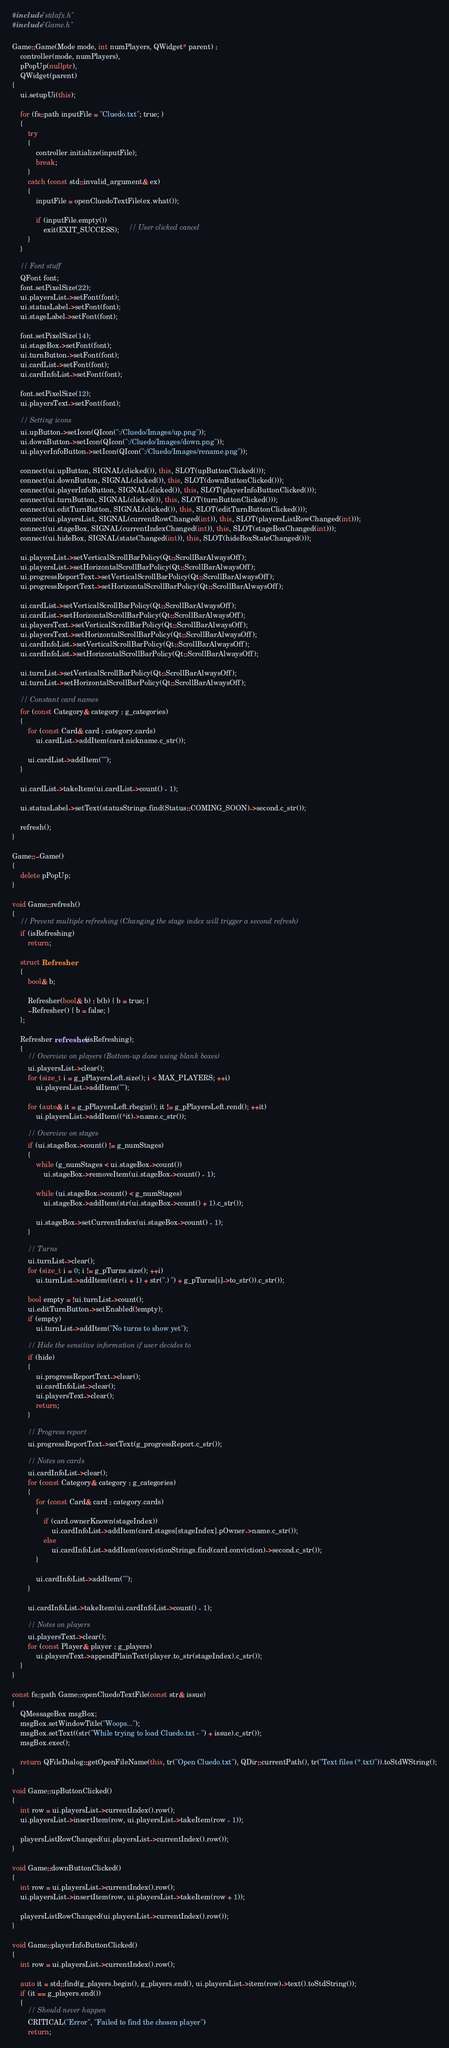<code> <loc_0><loc_0><loc_500><loc_500><_C++_>#include "stdafx.h"
#include "Game.h"

Game::Game(Mode mode, int numPlayers, QWidget* parent) :
    controller(mode, numPlayers),
    pPopUp(nullptr),
    QWidget(parent)
{
    ui.setupUi(this);

    for (fs::path inputFile = "Cluedo.txt"; true; )
    {
        try
        {
            controller.initialize(inputFile);
            break;
        }
        catch (const std::invalid_argument& ex)
        {
            inputFile = openCluedoTextFile(ex.what());

            if (inputFile.empty())
                exit(EXIT_SUCCESS);     // User clicked cancel
        }
    }

    // Font stuff
    QFont font;
    font.setPixelSize(22);
    ui.playersList->setFont(font);
    ui.statusLabel->setFont(font);
    ui.stageLabel->setFont(font);
    
    font.setPixelSize(14);
    ui.stageBox->setFont(font);
    ui.turnButton->setFont(font);
    ui.cardList->setFont(font);
    ui.cardInfoList->setFont(font);

    font.setPixelSize(12);
    ui.playersText->setFont(font);

    // Setting icons
    ui.upButton->setIcon(QIcon(":/Cluedo/Images/up.png"));
    ui.downButton->setIcon(QIcon(":/Cluedo/Images/down.png"));
    ui.playerInfoButton->setIcon(QIcon(":/Cluedo/Images/rename.png"));

    connect(ui.upButton, SIGNAL(clicked()), this, SLOT(upButtonClicked()));
    connect(ui.downButton, SIGNAL(clicked()), this, SLOT(downButtonClicked()));
    connect(ui.playerInfoButton, SIGNAL(clicked()), this, SLOT(playerInfoButtonClicked()));
    connect(ui.turnButton, SIGNAL(clicked()), this, SLOT(turnButtonClicked()));
    connect(ui.editTurnButton, SIGNAL(clicked()), this, SLOT(editTurnButtonClicked()));
    connect(ui.playersList, SIGNAL(currentRowChanged(int)), this, SLOT(playersListRowChanged(int)));
    connect(ui.stageBox, SIGNAL(currentIndexChanged(int)), this, SLOT(stageBoxChanged(int)));
    connect(ui.hideBox, SIGNAL(stateChanged(int)), this, SLOT(hideBoxStateChanged()));

    ui.playersList->setVerticalScrollBarPolicy(Qt::ScrollBarAlwaysOff);
    ui.playersList->setHorizontalScrollBarPolicy(Qt::ScrollBarAlwaysOff);
    ui.progressReportText->setVerticalScrollBarPolicy(Qt::ScrollBarAlwaysOff);
    ui.progressReportText->setHorizontalScrollBarPolicy(Qt::ScrollBarAlwaysOff);

    ui.cardList->setVerticalScrollBarPolicy(Qt::ScrollBarAlwaysOff);
    ui.cardList->setHorizontalScrollBarPolicy(Qt::ScrollBarAlwaysOff);
    ui.playersText->setVerticalScrollBarPolicy(Qt::ScrollBarAlwaysOff);
    ui.playersText->setHorizontalScrollBarPolicy(Qt::ScrollBarAlwaysOff);
    ui.cardInfoList->setVerticalScrollBarPolicy(Qt::ScrollBarAlwaysOff);
    ui.cardInfoList->setHorizontalScrollBarPolicy(Qt::ScrollBarAlwaysOff);

    ui.turnList->setVerticalScrollBarPolicy(Qt::ScrollBarAlwaysOff);
    ui.turnList->setHorizontalScrollBarPolicy(Qt::ScrollBarAlwaysOff);

    // Constant card names
    for (const Category& category : g_categories)
    {
        for (const Card& card : category.cards)
            ui.cardList->addItem(card.nickname.c_str());

        ui.cardList->addItem("");
    }

    ui.cardList->takeItem(ui.cardList->count() - 1);

    ui.statusLabel->setText(statusStrings.find(Status::COMING_SOON)->second.c_str());

    refresh();
}

Game::~Game()
{
    delete pPopUp;
}

void Game::refresh()
{
    // Prevent multiple refreshing (Changing the stage index will trigger a second refresh)
    if (isRefreshing)
        return;

    struct Refresher
    {
        bool& b;

        Refresher(bool& b) : b(b) { b = true; }
        ~Refresher() { b = false; }
    };

    Refresher refresher(isRefreshing);
    {
        // Overview on players (Bottom-up done using blank boxes)
        ui.playersList->clear();
        for (size_t i = g_pPlayersLeft.size(); i < MAX_PLAYERS; ++i)
            ui.playersList->addItem("");

        for (auto& it = g_pPlayersLeft.rbegin(); it != g_pPlayersLeft.rend(); ++it)
            ui.playersList->addItem((*it)->name.c_str());

        // Overview on stages
        if (ui.stageBox->count() != g_numStages)
        {
            while (g_numStages < ui.stageBox->count())
                ui.stageBox->removeItem(ui.stageBox->count() - 1);

            while (ui.stageBox->count() < g_numStages)
                ui.stageBox->addItem(str(ui.stageBox->count() + 1).c_str());

            ui.stageBox->setCurrentIndex(ui.stageBox->count() - 1);
        }

        // Turns
        ui.turnList->clear();
        for (size_t i = 0; i != g_pTurns.size(); ++i)
            ui.turnList->addItem((str(i + 1) + str(".) ") + g_pTurns[i]->to_str()).c_str());

        bool empty = !ui.turnList->count();
        ui.editTurnButton->setEnabled(!empty);
        if (empty)
            ui.turnList->addItem("No turns to show yet");

        // Hide the sensitive information if user decides to
        if (hide)
        {
            ui.progressReportText->clear();
            ui.cardInfoList->clear();
            ui.playersText->clear();
            return;
        }

        // Progress report
        ui.progressReportText->setText(g_progressReport.c_str());

        // Notes on cards
        ui.cardInfoList->clear();
        for (const Category& category : g_categories)
        {
            for (const Card& card : category.cards)
            {
                if (card.ownerKnown(stageIndex))
                    ui.cardInfoList->addItem(card.stages[stageIndex].pOwner->name.c_str());
                else
                    ui.cardInfoList->addItem(convictionStrings.find(card.conviction)->second.c_str());
            }

            ui.cardInfoList->addItem("");
        }

        ui.cardInfoList->takeItem(ui.cardInfoList->count() - 1);

        // Notes on players
        ui.playersText->clear();
        for (const Player& player : g_players)
            ui.playersText->appendPlainText(player.to_str(stageIndex).c_str());
    }
}

const fs::path Game::openCluedoTextFile(const str& issue)
{
    QMessageBox msgBox;
    msgBox.setWindowTitle("Woops...");
    msgBox.setText((str("While trying to load Cluedo.txt - ") + issue).c_str());
    msgBox.exec();

    return QFileDialog::getOpenFileName(this, tr("Open Cluedo.txt"), QDir::currentPath(), tr("Text files (*.txt)")).toStdWString();
}

void Game::upButtonClicked()
{
    int row = ui.playersList->currentIndex().row();
    ui.playersList->insertItem(row, ui.playersList->takeItem(row - 1));

    playersListRowChanged(ui.playersList->currentIndex().row());
}

void Game::downButtonClicked()
{
    int row = ui.playersList->currentIndex().row();
    ui.playersList->insertItem(row, ui.playersList->takeItem(row + 1));

    playersListRowChanged(ui.playersList->currentIndex().row());
}

void Game::playerInfoButtonClicked()
{
    int row = ui.playersList->currentIndex().row();

    auto it = std::find(g_players.begin(), g_players.end(), ui.playersList->item(row)->text().toStdString());
    if (it == g_players.end())
    {
        // Should never happen
        CRITICAL("Error", "Failed to find the chosen player")
        return;</code> 